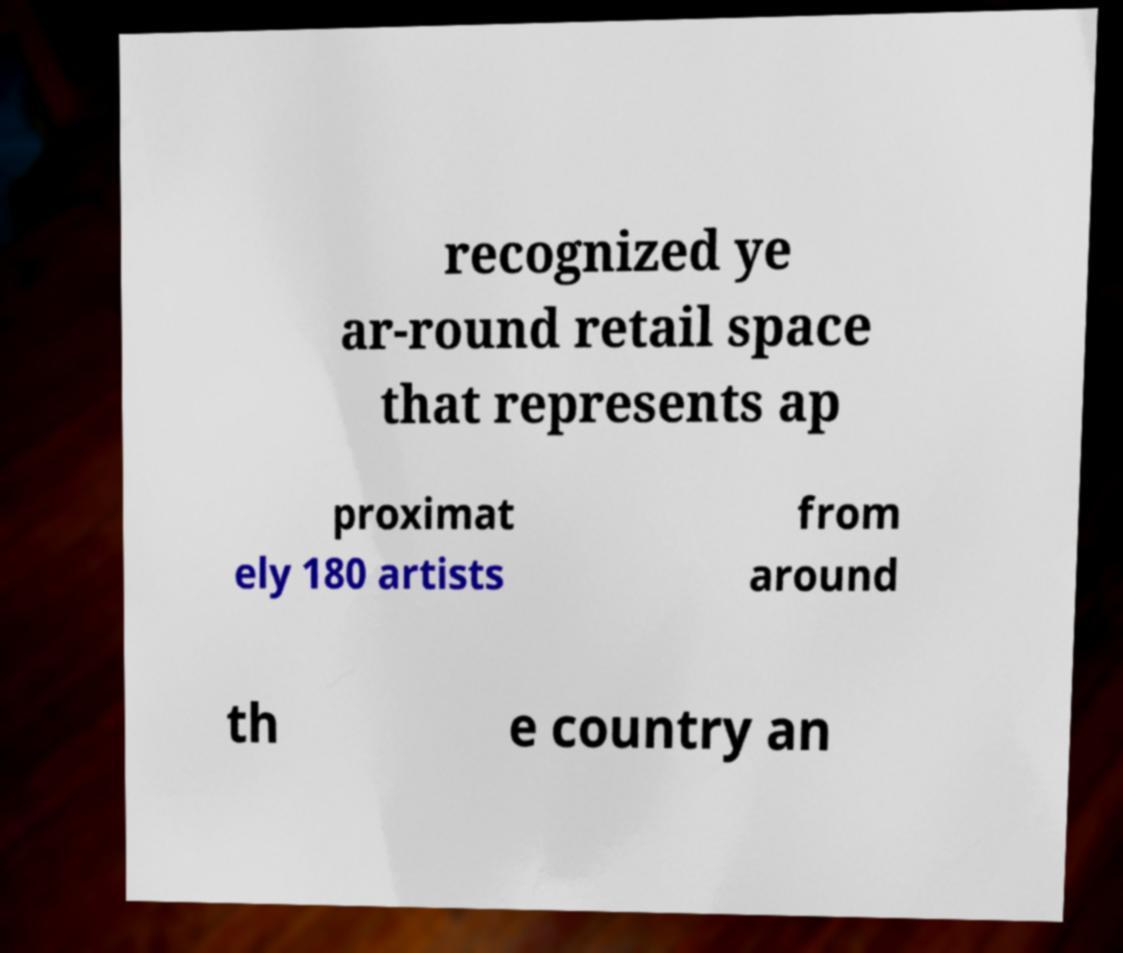Could you extract and type out the text from this image? recognized ye ar-round retail space that represents ap proximat ely 180 artists from around th e country an 